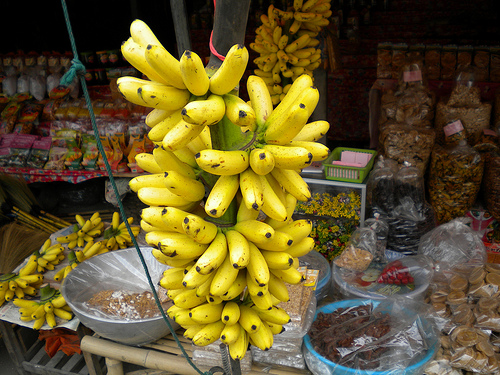What items can be seen in the background? The background of the image is bustling with market goods including bags of snacks, arrays of spices, and other miscellaneous grocery items, arranged in a lively and inviting format. Could you describe any textures or materials visible in these items? Sure, various textures can be seen such as the rough, natural fibers of the hand-woven baskets, the crinkly plastic of snack bags, and the smooth, organic shapes of the spices adding a multisensory appeal to the scene. 